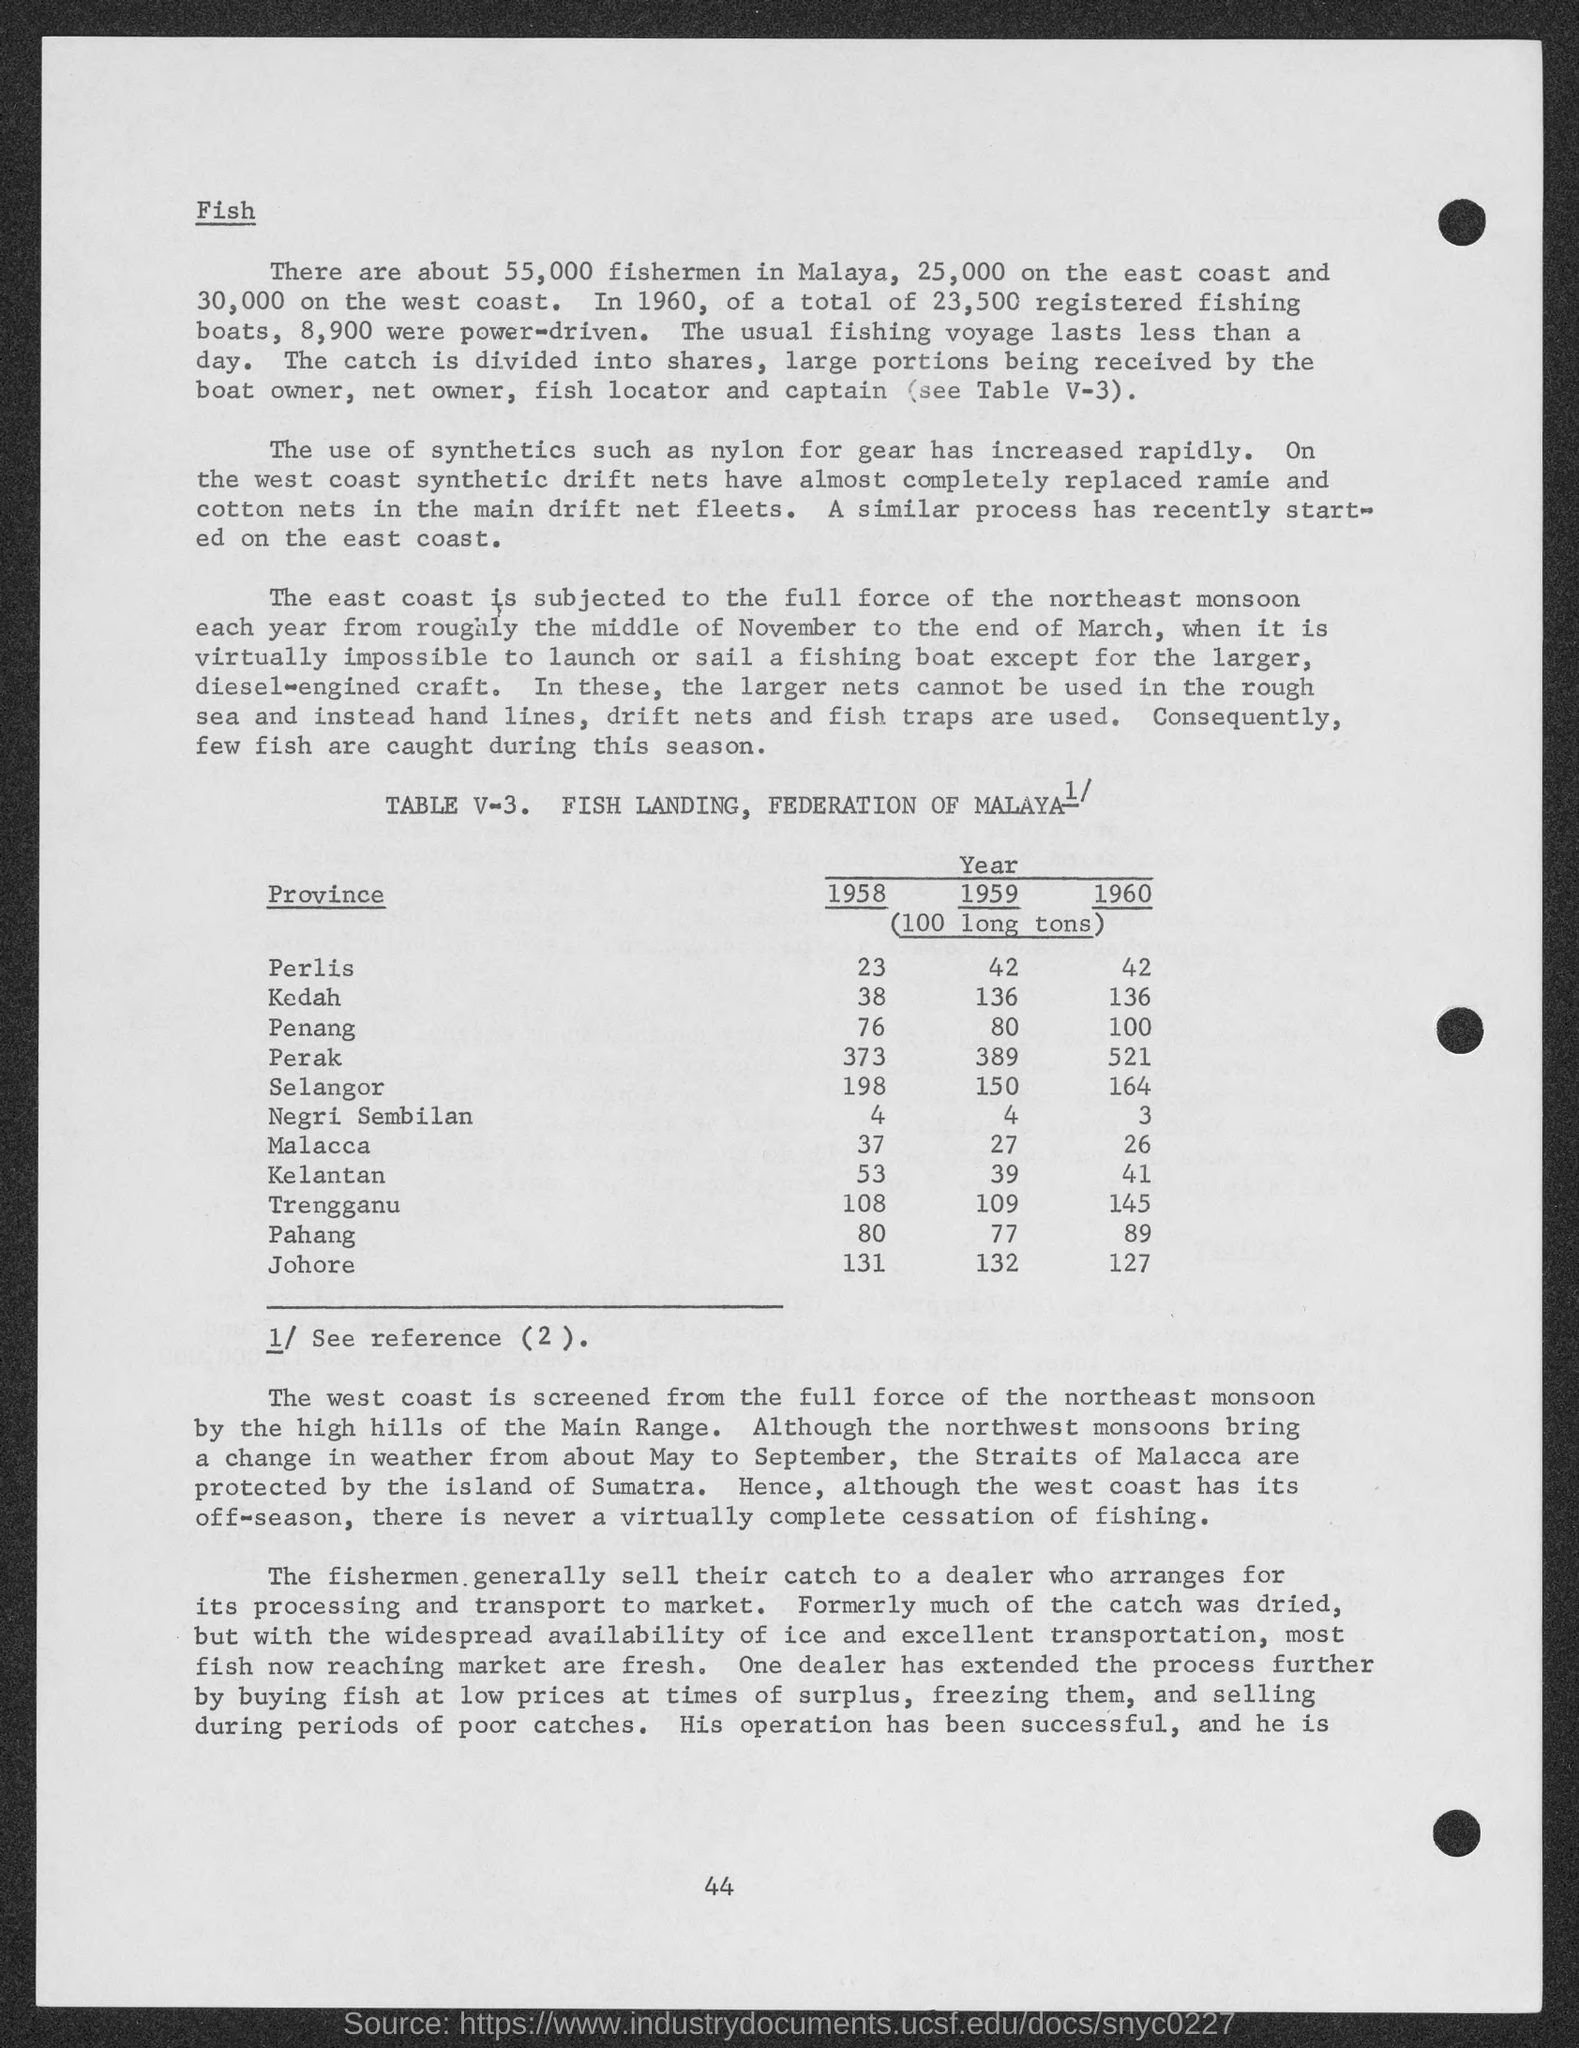What is the number at bottom of the page ?
Provide a succinct answer. 44. What is the amount of (100 long tons ) in 1958 of perils ?
Your response must be concise. 23. What is the amount of (100 long tons ) in 1958 of kedah?
Make the answer very short. 38. What is the amount of (100 long tons ) in 1958 of penang ?
Provide a succinct answer. 76. What is the amount of (100 long tons ) in 1958 of perak ?
Make the answer very short. 373. What is the amount of (100 long tons ) in 1958 of selangor ?
Ensure brevity in your answer.  198. What is the amount of (100 long tons ) in 1958 of negri sembilan ?
Keep it short and to the point. 4. What is the amount of (100 long tons ) in 1958 of malacca ?
Provide a short and direct response. 37. What is the amount of (100 long tons ) in 1958 of kelantan ?
Your response must be concise. 53. What is the amount of (100 long tons ) in 1958 of  trengganu ?
Your answer should be compact. 108. 